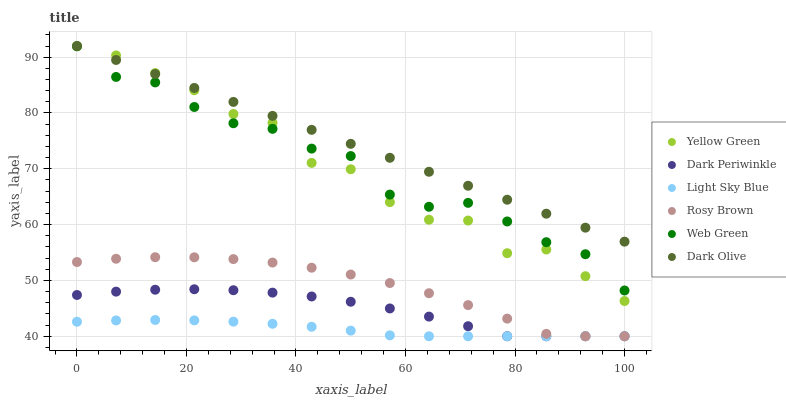Does Light Sky Blue have the minimum area under the curve?
Answer yes or no. Yes. Does Dark Olive have the maximum area under the curve?
Answer yes or no. Yes. Does Yellow Green have the minimum area under the curve?
Answer yes or no. No. Does Yellow Green have the maximum area under the curve?
Answer yes or no. No. Is Dark Olive the smoothest?
Answer yes or no. Yes. Is Yellow Green the roughest?
Answer yes or no. Yes. Is Yellow Green the smoothest?
Answer yes or no. No. Is Dark Olive the roughest?
Answer yes or no. No. Does Rosy Brown have the lowest value?
Answer yes or no. Yes. Does Yellow Green have the lowest value?
Answer yes or no. No. Does Dark Olive have the highest value?
Answer yes or no. Yes. Does Web Green have the highest value?
Answer yes or no. No. Is Rosy Brown less than Web Green?
Answer yes or no. Yes. Is Dark Olive greater than Rosy Brown?
Answer yes or no. Yes. Does Yellow Green intersect Dark Olive?
Answer yes or no. Yes. Is Yellow Green less than Dark Olive?
Answer yes or no. No. Is Yellow Green greater than Dark Olive?
Answer yes or no. No. Does Rosy Brown intersect Web Green?
Answer yes or no. No. 